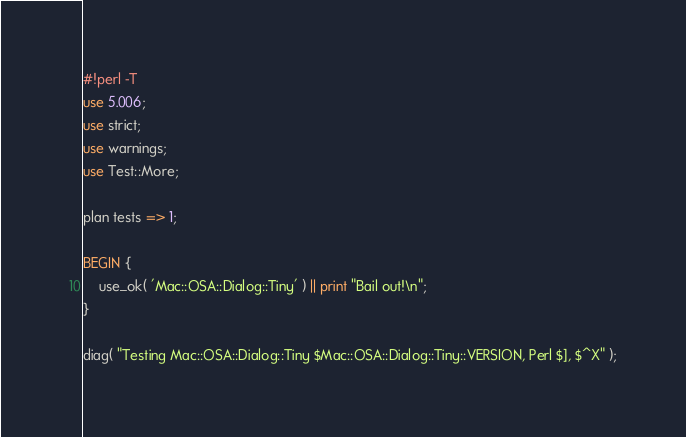<code> <loc_0><loc_0><loc_500><loc_500><_Perl_>#!perl -T
use 5.006;
use strict;
use warnings;
use Test::More;

plan tests => 1;

BEGIN {
    use_ok( 'Mac::OSA::Dialog::Tiny' ) || print "Bail out!\n";
}

diag( "Testing Mac::OSA::Dialog::Tiny $Mac::OSA::Dialog::Tiny::VERSION, Perl $], $^X" );
</code> 